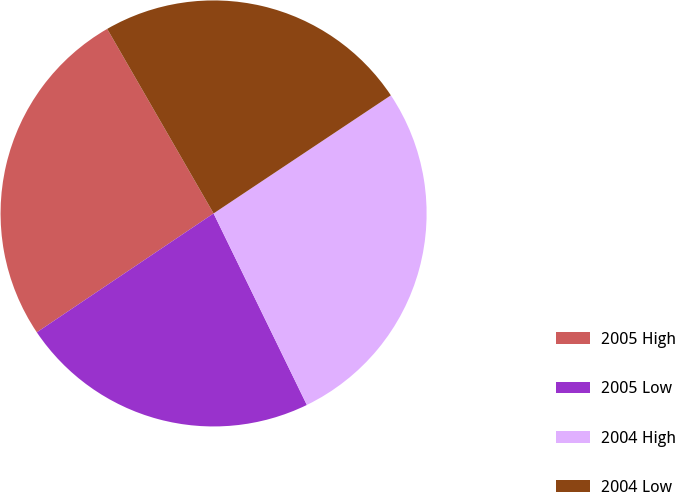<chart> <loc_0><loc_0><loc_500><loc_500><pie_chart><fcel>2005 High<fcel>2005 Low<fcel>2004 High<fcel>2004 Low<nl><fcel>26.1%<fcel>22.79%<fcel>27.14%<fcel>23.97%<nl></chart> 